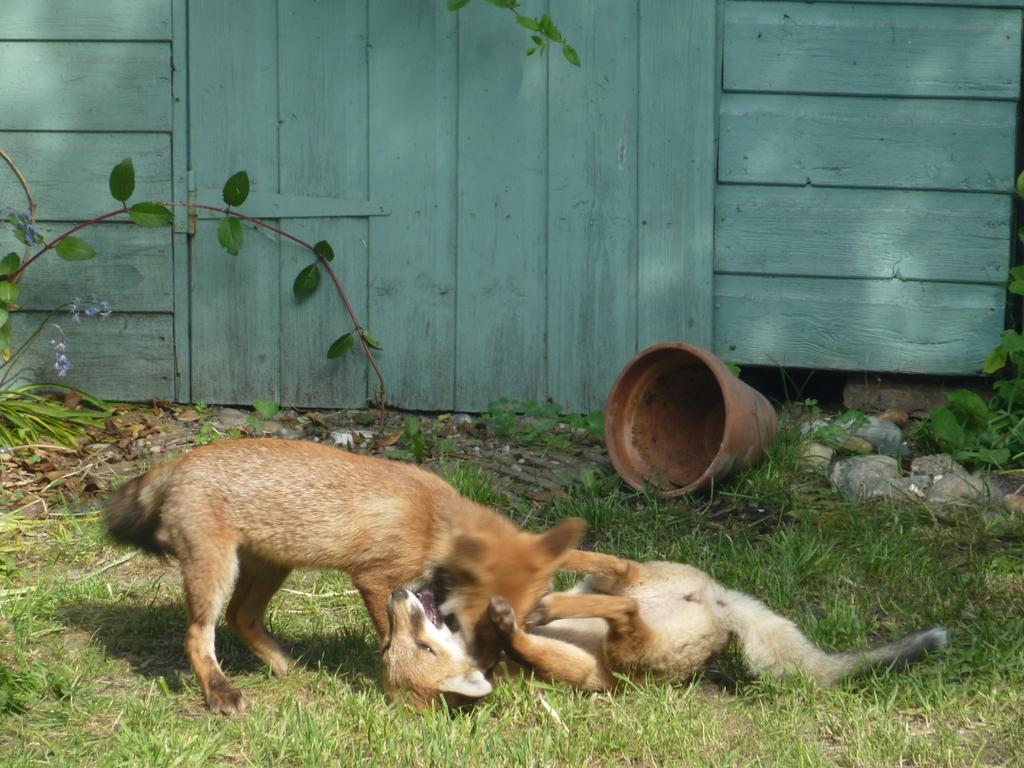Describe this image in one or two sentences. In this image we can see two animals on the ground, there is a flower pot, stones, plants and a wooden wall with door in the background. 